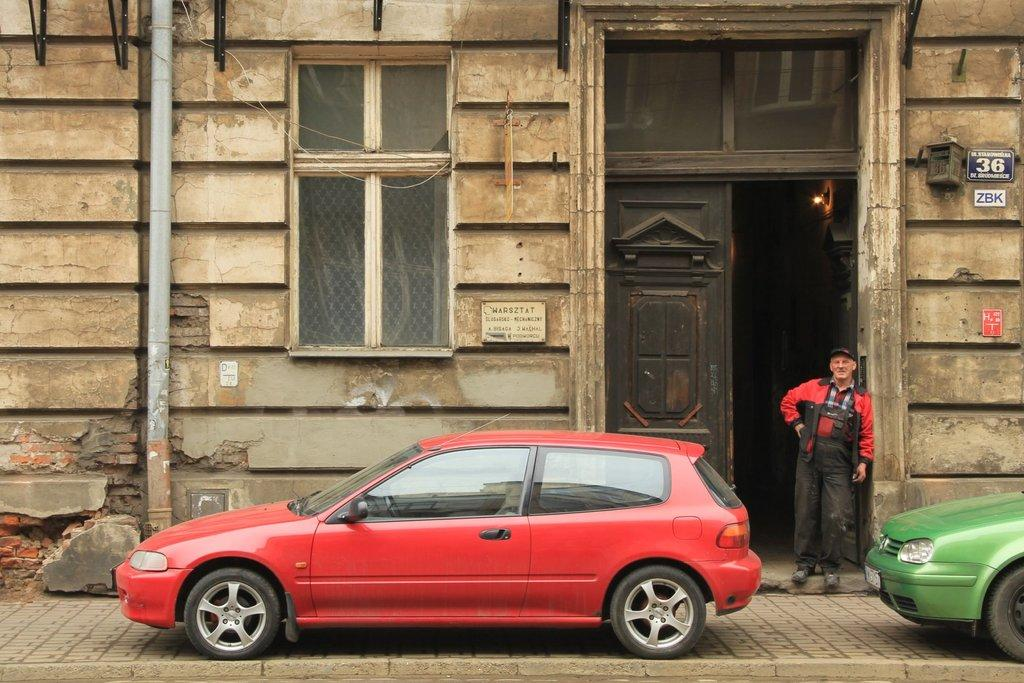How many cars are visible in the image? There are two cars in the image. What type of structure is present in the image? There is a building with windows and doors in the image. Can you describe the person near the building? A person wearing a cap is standing near the door of the building. What additional detail can be seen on the building? There is a number on the wall of the building. What type of vegetable is being harvested in the image? There is no vegetable being harvested in the image; it features two cars, a building, and a person standing near the door. How many cows are visible in the image? There are no cows present in the image. 